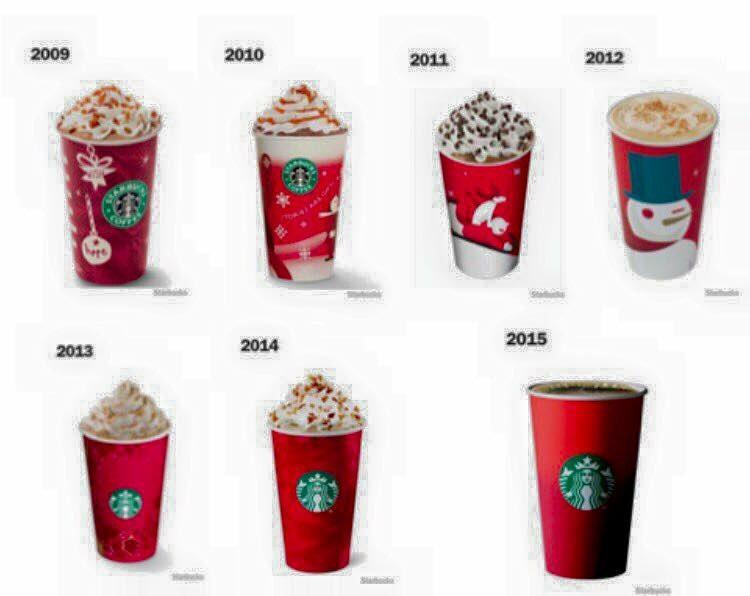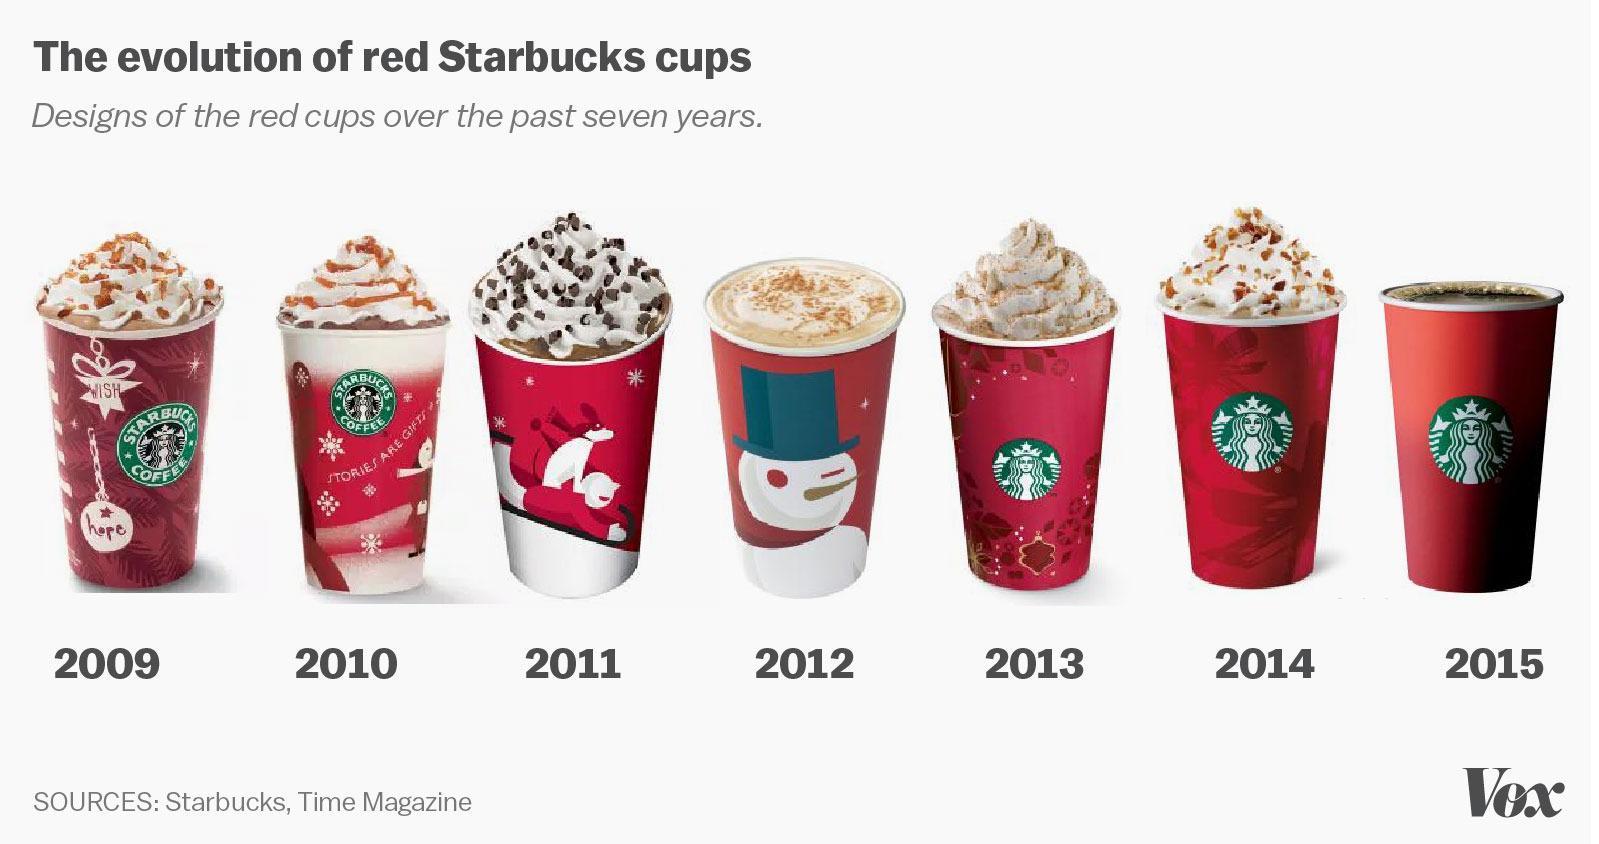The first image is the image on the left, the second image is the image on the right. Assess this claim about the two images: "In at least one image there are seven red starbucks christmas cups full of coffee.". Correct or not? Answer yes or no. Yes. 